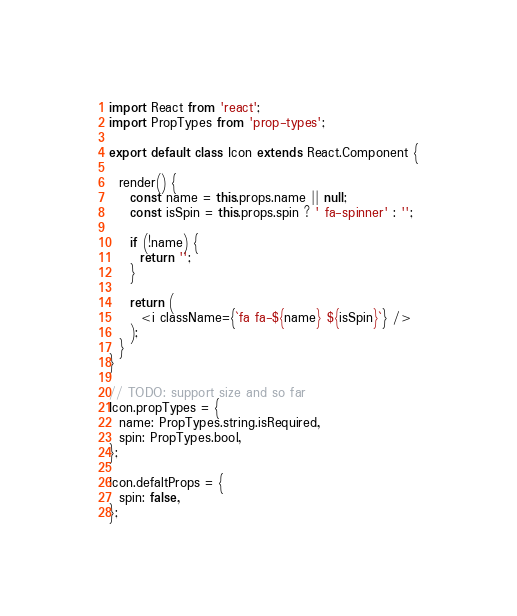<code> <loc_0><loc_0><loc_500><loc_500><_JavaScript_>import React from 'react';
import PropTypes from 'prop-types';

export default class Icon extends React.Component {

  render() {
    const name = this.props.name || null;
    const isSpin = this.props.spin ? ' fa-spinner' : '';

    if (!name) {
      return '';
    }

    return (
      <i className={`fa fa-${name} ${isSpin}`} />
    );
  }
}

// TODO: support size and so far
Icon.propTypes = {
  name: PropTypes.string.isRequired,
  spin: PropTypes.bool,
};

Icon.defaltProps = {
  spin: false,
};

</code> 